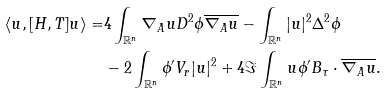Convert formula to latex. <formula><loc_0><loc_0><loc_500><loc_500>\langle u , [ H , T ] u \rangle = & 4 \int _ { \mathbb { R } ^ { n } } \nabla _ { A } u D ^ { 2 } \phi \overline { \nabla _ { A } u } - \int _ { \mathbb { R } ^ { n } } | u | ^ { 2 } \Delta ^ { 2 } \phi \\ & - 2 \int _ { \mathbb { R } ^ { n } } \phi ^ { \prime } V _ { r } | u | ^ { 2 } + 4 \Im \int _ { \mathbb { R } ^ { n } } u \phi ^ { \prime } B _ { \tau } \cdot \overline { \nabla _ { A } u } .</formula> 